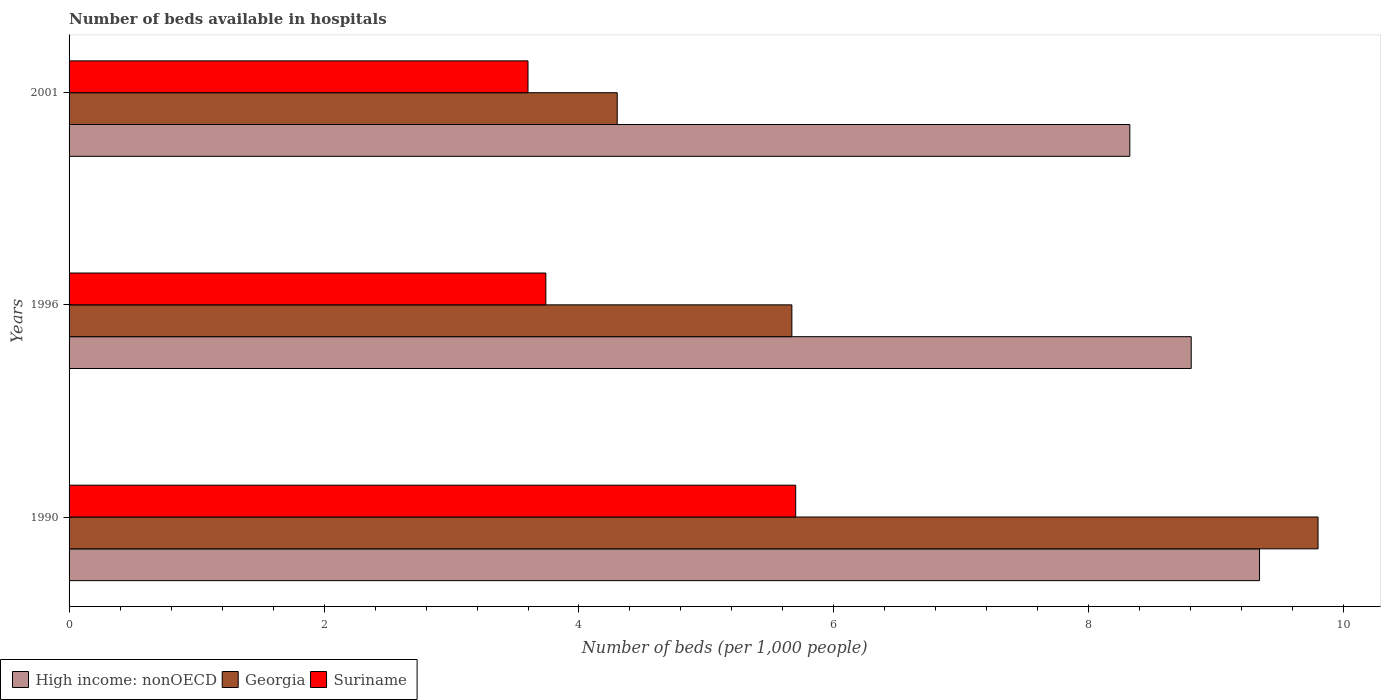How many different coloured bars are there?
Offer a very short reply. 3. Are the number of bars per tick equal to the number of legend labels?
Offer a very short reply. Yes. How many bars are there on the 3rd tick from the top?
Your answer should be compact. 3. How many bars are there on the 3rd tick from the bottom?
Your answer should be compact. 3. What is the number of beds in the hospiatls of in High income: nonOECD in 1990?
Provide a succinct answer. 9.34. Across all years, what is the maximum number of beds in the hospiatls of in Georgia?
Your answer should be very brief. 9.8. Across all years, what is the minimum number of beds in the hospiatls of in Georgia?
Give a very brief answer. 4.3. In which year was the number of beds in the hospiatls of in High income: nonOECD maximum?
Your answer should be compact. 1990. In which year was the number of beds in the hospiatls of in Suriname minimum?
Give a very brief answer. 2001. What is the total number of beds in the hospiatls of in Georgia in the graph?
Give a very brief answer. 19.77. What is the difference between the number of beds in the hospiatls of in Georgia in 1996 and that in 2001?
Your answer should be compact. 1.37. What is the difference between the number of beds in the hospiatls of in Georgia in 1996 and the number of beds in the hospiatls of in Suriname in 2001?
Ensure brevity in your answer.  2.07. What is the average number of beds in the hospiatls of in Suriname per year?
Provide a succinct answer. 4.35. In the year 2001, what is the difference between the number of beds in the hospiatls of in High income: nonOECD and number of beds in the hospiatls of in Suriname?
Offer a terse response. 4.72. What is the ratio of the number of beds in the hospiatls of in High income: nonOECD in 1990 to that in 2001?
Your answer should be compact. 1.12. Is the number of beds in the hospiatls of in Suriname in 1990 less than that in 2001?
Keep it short and to the point. No. Is the difference between the number of beds in the hospiatls of in High income: nonOECD in 1996 and 2001 greater than the difference between the number of beds in the hospiatls of in Suriname in 1996 and 2001?
Offer a terse response. Yes. What is the difference between the highest and the second highest number of beds in the hospiatls of in Georgia?
Keep it short and to the point. 4.13. What is the difference between the highest and the lowest number of beds in the hospiatls of in Suriname?
Provide a succinct answer. 2.1. Is the sum of the number of beds in the hospiatls of in Georgia in 1990 and 1996 greater than the maximum number of beds in the hospiatls of in High income: nonOECD across all years?
Give a very brief answer. Yes. What does the 1st bar from the top in 1996 represents?
Offer a very short reply. Suriname. What does the 3rd bar from the bottom in 2001 represents?
Make the answer very short. Suriname. How many bars are there?
Give a very brief answer. 9. How many years are there in the graph?
Your response must be concise. 3. Does the graph contain any zero values?
Make the answer very short. No. Does the graph contain grids?
Your answer should be very brief. No. How many legend labels are there?
Your answer should be very brief. 3. How are the legend labels stacked?
Make the answer very short. Horizontal. What is the title of the graph?
Ensure brevity in your answer.  Number of beds available in hospitals. Does "Portugal" appear as one of the legend labels in the graph?
Make the answer very short. No. What is the label or title of the X-axis?
Make the answer very short. Number of beds (per 1,0 people). What is the Number of beds (per 1,000 people) of High income: nonOECD in 1990?
Give a very brief answer. 9.34. What is the Number of beds (per 1,000 people) in Georgia in 1990?
Provide a short and direct response. 9.8. What is the Number of beds (per 1,000 people) of Suriname in 1990?
Make the answer very short. 5.7. What is the Number of beds (per 1,000 people) in High income: nonOECD in 1996?
Your response must be concise. 8.8. What is the Number of beds (per 1,000 people) in Georgia in 1996?
Offer a very short reply. 5.67. What is the Number of beds (per 1,000 people) of Suriname in 1996?
Offer a very short reply. 3.74. What is the Number of beds (per 1,000 people) in High income: nonOECD in 2001?
Ensure brevity in your answer.  8.32. What is the Number of beds (per 1,000 people) in Georgia in 2001?
Ensure brevity in your answer.  4.3. What is the Number of beds (per 1,000 people) of Suriname in 2001?
Ensure brevity in your answer.  3.6. Across all years, what is the maximum Number of beds (per 1,000 people) of High income: nonOECD?
Your answer should be very brief. 9.34. Across all years, what is the maximum Number of beds (per 1,000 people) in Georgia?
Make the answer very short. 9.8. Across all years, what is the maximum Number of beds (per 1,000 people) in Suriname?
Ensure brevity in your answer.  5.7. Across all years, what is the minimum Number of beds (per 1,000 people) of High income: nonOECD?
Offer a terse response. 8.32. Across all years, what is the minimum Number of beds (per 1,000 people) of Georgia?
Your response must be concise. 4.3. Across all years, what is the minimum Number of beds (per 1,000 people) of Suriname?
Your answer should be very brief. 3.6. What is the total Number of beds (per 1,000 people) of High income: nonOECD in the graph?
Provide a short and direct response. 26.46. What is the total Number of beds (per 1,000 people) in Georgia in the graph?
Offer a terse response. 19.77. What is the total Number of beds (per 1,000 people) of Suriname in the graph?
Provide a short and direct response. 13.04. What is the difference between the Number of beds (per 1,000 people) in High income: nonOECD in 1990 and that in 1996?
Give a very brief answer. 0.54. What is the difference between the Number of beds (per 1,000 people) in Georgia in 1990 and that in 1996?
Keep it short and to the point. 4.13. What is the difference between the Number of beds (per 1,000 people) of Suriname in 1990 and that in 1996?
Make the answer very short. 1.96. What is the difference between the Number of beds (per 1,000 people) in High income: nonOECD in 1990 and that in 2001?
Your response must be concise. 1.02. What is the difference between the Number of beds (per 1,000 people) in Georgia in 1990 and that in 2001?
Ensure brevity in your answer.  5.5. What is the difference between the Number of beds (per 1,000 people) in Suriname in 1990 and that in 2001?
Offer a very short reply. 2.1. What is the difference between the Number of beds (per 1,000 people) in High income: nonOECD in 1996 and that in 2001?
Your answer should be very brief. 0.48. What is the difference between the Number of beds (per 1,000 people) of Georgia in 1996 and that in 2001?
Your response must be concise. 1.37. What is the difference between the Number of beds (per 1,000 people) in Suriname in 1996 and that in 2001?
Your answer should be compact. 0.14. What is the difference between the Number of beds (per 1,000 people) in High income: nonOECD in 1990 and the Number of beds (per 1,000 people) in Georgia in 1996?
Your response must be concise. 3.67. What is the difference between the Number of beds (per 1,000 people) in High income: nonOECD in 1990 and the Number of beds (per 1,000 people) in Suriname in 1996?
Offer a very short reply. 5.6. What is the difference between the Number of beds (per 1,000 people) of Georgia in 1990 and the Number of beds (per 1,000 people) of Suriname in 1996?
Your answer should be very brief. 6.06. What is the difference between the Number of beds (per 1,000 people) of High income: nonOECD in 1990 and the Number of beds (per 1,000 people) of Georgia in 2001?
Your response must be concise. 5.04. What is the difference between the Number of beds (per 1,000 people) of High income: nonOECD in 1990 and the Number of beds (per 1,000 people) of Suriname in 2001?
Offer a very short reply. 5.74. What is the difference between the Number of beds (per 1,000 people) in Georgia in 1990 and the Number of beds (per 1,000 people) in Suriname in 2001?
Offer a very short reply. 6.2. What is the difference between the Number of beds (per 1,000 people) of High income: nonOECD in 1996 and the Number of beds (per 1,000 people) of Georgia in 2001?
Your answer should be very brief. 4.5. What is the difference between the Number of beds (per 1,000 people) of High income: nonOECD in 1996 and the Number of beds (per 1,000 people) of Suriname in 2001?
Keep it short and to the point. 5.2. What is the difference between the Number of beds (per 1,000 people) of Georgia in 1996 and the Number of beds (per 1,000 people) of Suriname in 2001?
Provide a short and direct response. 2.07. What is the average Number of beds (per 1,000 people) in High income: nonOECD per year?
Your answer should be very brief. 8.82. What is the average Number of beds (per 1,000 people) of Georgia per year?
Offer a terse response. 6.59. What is the average Number of beds (per 1,000 people) in Suriname per year?
Provide a short and direct response. 4.35. In the year 1990, what is the difference between the Number of beds (per 1,000 people) of High income: nonOECD and Number of beds (per 1,000 people) of Georgia?
Offer a very short reply. -0.46. In the year 1990, what is the difference between the Number of beds (per 1,000 people) in High income: nonOECD and Number of beds (per 1,000 people) in Suriname?
Keep it short and to the point. 3.64. In the year 1990, what is the difference between the Number of beds (per 1,000 people) in Georgia and Number of beds (per 1,000 people) in Suriname?
Your response must be concise. 4.1. In the year 1996, what is the difference between the Number of beds (per 1,000 people) of High income: nonOECD and Number of beds (per 1,000 people) of Georgia?
Ensure brevity in your answer.  3.13. In the year 1996, what is the difference between the Number of beds (per 1,000 people) in High income: nonOECD and Number of beds (per 1,000 people) in Suriname?
Ensure brevity in your answer.  5.06. In the year 1996, what is the difference between the Number of beds (per 1,000 people) of Georgia and Number of beds (per 1,000 people) of Suriname?
Ensure brevity in your answer.  1.93. In the year 2001, what is the difference between the Number of beds (per 1,000 people) in High income: nonOECD and Number of beds (per 1,000 people) in Georgia?
Make the answer very short. 4.02. In the year 2001, what is the difference between the Number of beds (per 1,000 people) of High income: nonOECD and Number of beds (per 1,000 people) of Suriname?
Give a very brief answer. 4.72. In the year 2001, what is the difference between the Number of beds (per 1,000 people) in Georgia and Number of beds (per 1,000 people) in Suriname?
Give a very brief answer. 0.7. What is the ratio of the Number of beds (per 1,000 people) of High income: nonOECD in 1990 to that in 1996?
Your answer should be very brief. 1.06. What is the ratio of the Number of beds (per 1,000 people) in Georgia in 1990 to that in 1996?
Offer a very short reply. 1.73. What is the ratio of the Number of beds (per 1,000 people) in Suriname in 1990 to that in 1996?
Your answer should be compact. 1.52. What is the ratio of the Number of beds (per 1,000 people) of High income: nonOECD in 1990 to that in 2001?
Provide a succinct answer. 1.12. What is the ratio of the Number of beds (per 1,000 people) in Georgia in 1990 to that in 2001?
Offer a very short reply. 2.28. What is the ratio of the Number of beds (per 1,000 people) in Suriname in 1990 to that in 2001?
Keep it short and to the point. 1.58. What is the ratio of the Number of beds (per 1,000 people) in High income: nonOECD in 1996 to that in 2001?
Your answer should be compact. 1.06. What is the ratio of the Number of beds (per 1,000 people) in Georgia in 1996 to that in 2001?
Provide a succinct answer. 1.32. What is the ratio of the Number of beds (per 1,000 people) in Suriname in 1996 to that in 2001?
Your answer should be compact. 1.04. What is the difference between the highest and the second highest Number of beds (per 1,000 people) in High income: nonOECD?
Offer a terse response. 0.54. What is the difference between the highest and the second highest Number of beds (per 1,000 people) of Georgia?
Provide a succinct answer. 4.13. What is the difference between the highest and the second highest Number of beds (per 1,000 people) of Suriname?
Your answer should be compact. 1.96. What is the difference between the highest and the lowest Number of beds (per 1,000 people) of High income: nonOECD?
Offer a very short reply. 1.02. What is the difference between the highest and the lowest Number of beds (per 1,000 people) of Georgia?
Keep it short and to the point. 5.5. What is the difference between the highest and the lowest Number of beds (per 1,000 people) in Suriname?
Give a very brief answer. 2.1. 